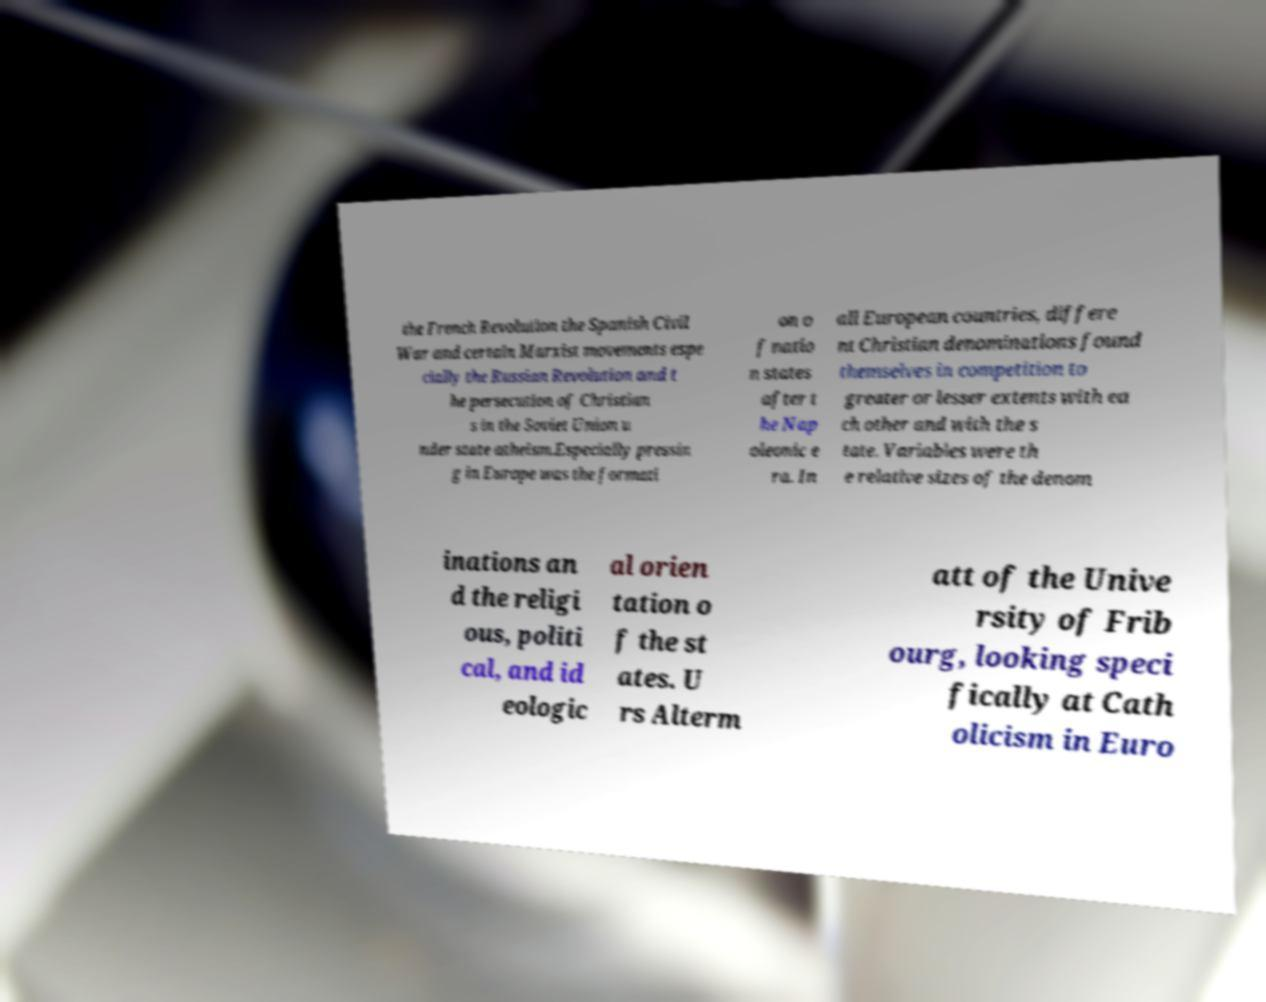Please identify and transcribe the text found in this image. the French Revolution the Spanish Civil War and certain Marxist movements espe cially the Russian Revolution and t he persecution of Christian s in the Soviet Union u nder state atheism.Especially pressin g in Europe was the formati on o f natio n states after t he Nap oleonic e ra. In all European countries, differe nt Christian denominations found themselves in competition to greater or lesser extents with ea ch other and with the s tate. Variables were th e relative sizes of the denom inations an d the religi ous, politi cal, and id eologic al orien tation o f the st ates. U rs Alterm att of the Unive rsity of Frib ourg, looking speci fically at Cath olicism in Euro 